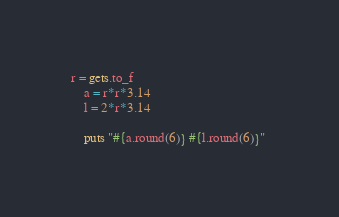Convert code to text. <code><loc_0><loc_0><loc_500><loc_500><_Ruby_>r = gets.to_f
	a = r*r*3.14
	l = 2*r*3.14

	puts "#{a.round(6)} #{l.round(6)}" </code> 